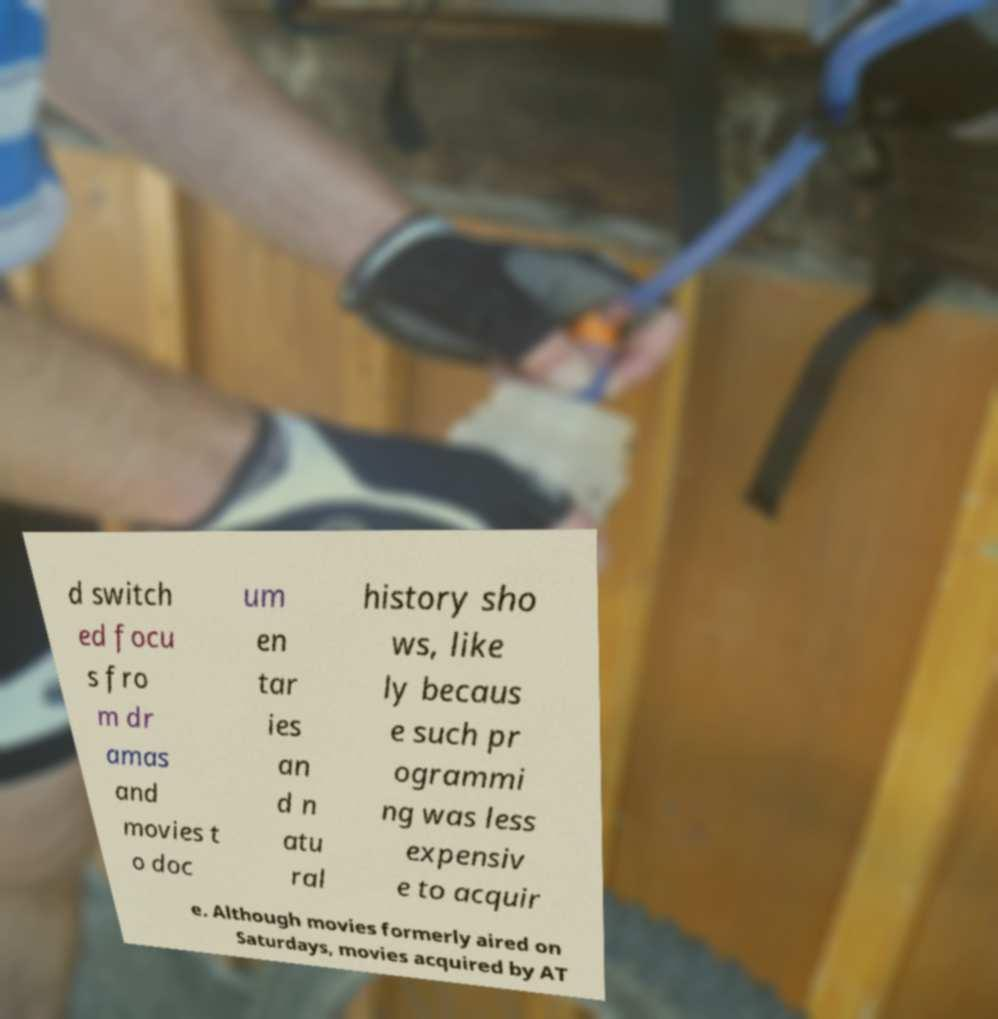What messages or text are displayed in this image? I need them in a readable, typed format. d switch ed focu s fro m dr amas and movies t o doc um en tar ies an d n atu ral history sho ws, like ly becaus e such pr ogrammi ng was less expensiv e to acquir e. Although movies formerly aired on Saturdays, movies acquired by AT 